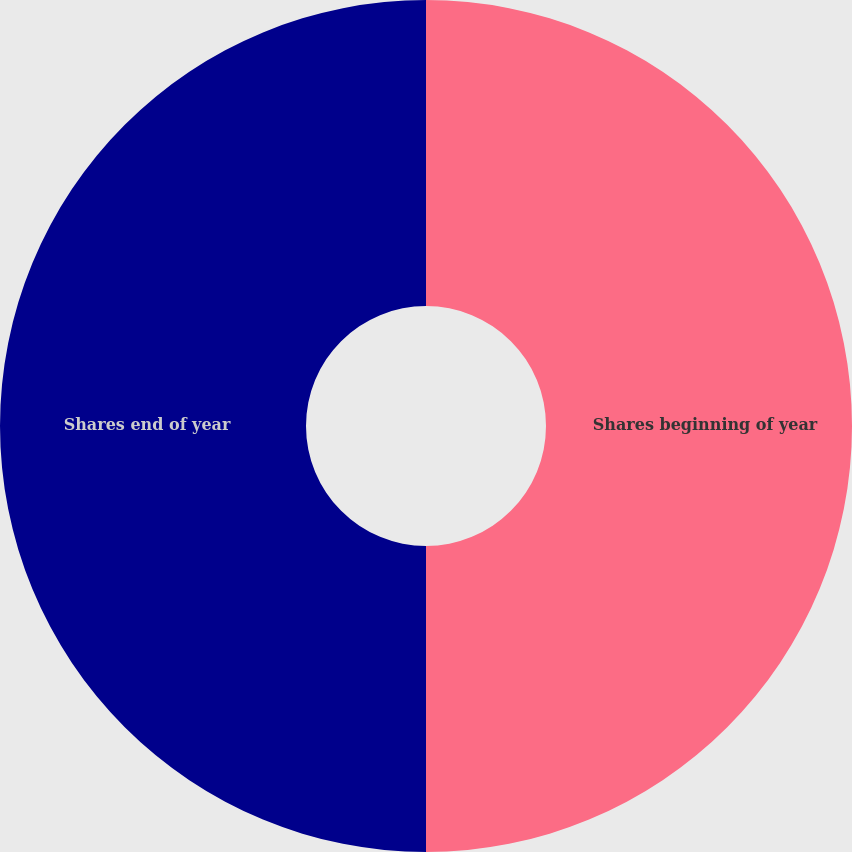<chart> <loc_0><loc_0><loc_500><loc_500><pie_chart><fcel>Shares beginning of year<fcel>Shares end of year<nl><fcel>50.0%<fcel>50.0%<nl></chart> 